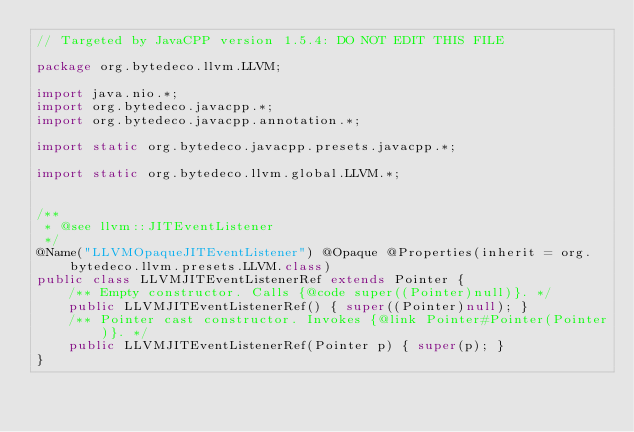Convert code to text. <code><loc_0><loc_0><loc_500><loc_500><_Java_>// Targeted by JavaCPP version 1.5.4: DO NOT EDIT THIS FILE

package org.bytedeco.llvm.LLVM;

import java.nio.*;
import org.bytedeco.javacpp.*;
import org.bytedeco.javacpp.annotation.*;

import static org.bytedeco.javacpp.presets.javacpp.*;

import static org.bytedeco.llvm.global.LLVM.*;


/**
 * @see llvm::JITEventListener
 */
@Name("LLVMOpaqueJITEventListener") @Opaque @Properties(inherit = org.bytedeco.llvm.presets.LLVM.class)
public class LLVMJITEventListenerRef extends Pointer {
    /** Empty constructor. Calls {@code super((Pointer)null)}. */
    public LLVMJITEventListenerRef() { super((Pointer)null); }
    /** Pointer cast constructor. Invokes {@link Pointer#Pointer(Pointer)}. */
    public LLVMJITEventListenerRef(Pointer p) { super(p); }
}
</code> 